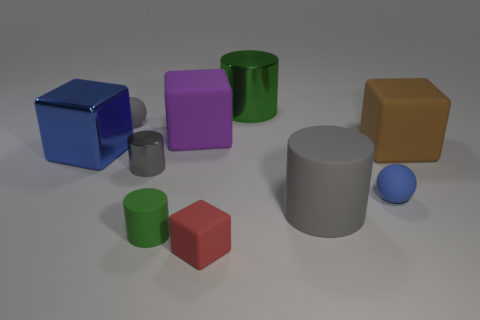How many other cylinders are the same color as the tiny rubber cylinder?
Keep it short and to the point. 1. What is the material of the object that is the same color as the metal block?
Provide a succinct answer. Rubber. How many tiny rubber spheres are both behind the large blue shiny thing and right of the big gray object?
Your answer should be very brief. 0. There is a green cylinder that is behind the large matte block on the right side of the tiny blue sphere; what is it made of?
Offer a very short reply. Metal. Is there a tiny thing made of the same material as the blue block?
Ensure brevity in your answer.  Yes. There is a block that is the same size as the green matte cylinder; what material is it?
Ensure brevity in your answer.  Rubber. How big is the thing that is behind the ball that is behind the small ball that is on the right side of the gray sphere?
Provide a succinct answer. Large. Are there any tiny objects behind the brown matte thing on the right side of the big green metallic object?
Keep it short and to the point. Yes. There is a small blue rubber object; is its shape the same as the gray rubber object that is on the left side of the small green object?
Provide a succinct answer. Yes. The shiny cylinder that is behind the big blue block is what color?
Your answer should be compact. Green. 